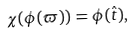<formula> <loc_0><loc_0><loc_500><loc_500>\chi ( \phi ( \varpi ) ) = \phi ( \hat { t } ) ,</formula> 